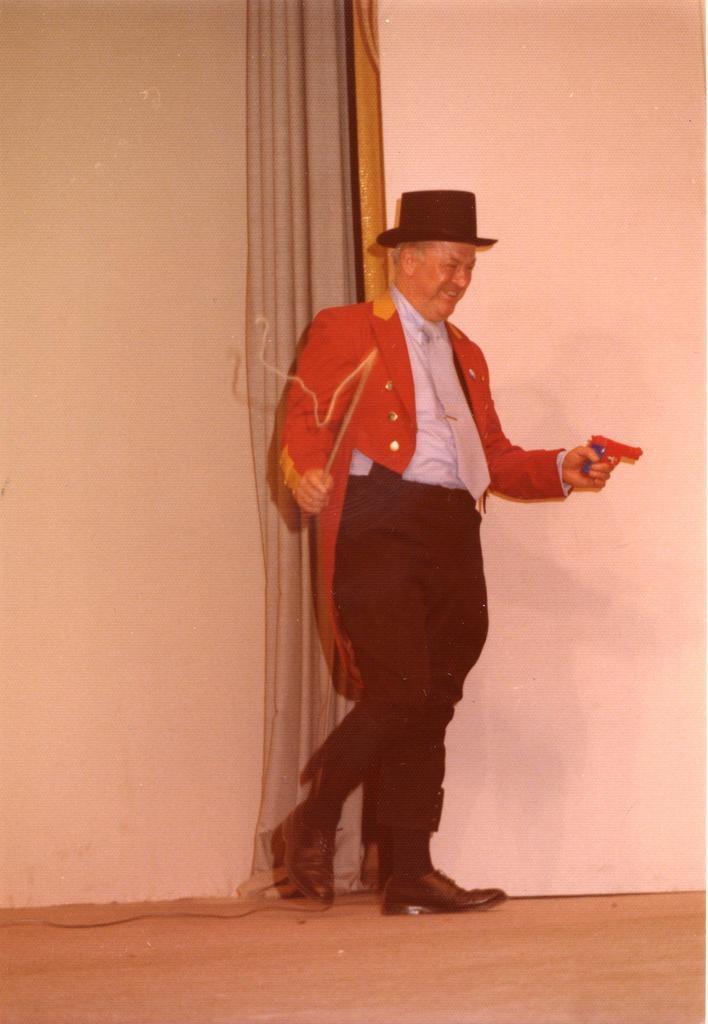Could you give a brief overview of what you see in this image? In the picture we can see a man standing in the red color blazer, white shirt and wearing a hat and holding a gun, which is red in color and in the behind him we can see a wall with a curtain which is white in color. 